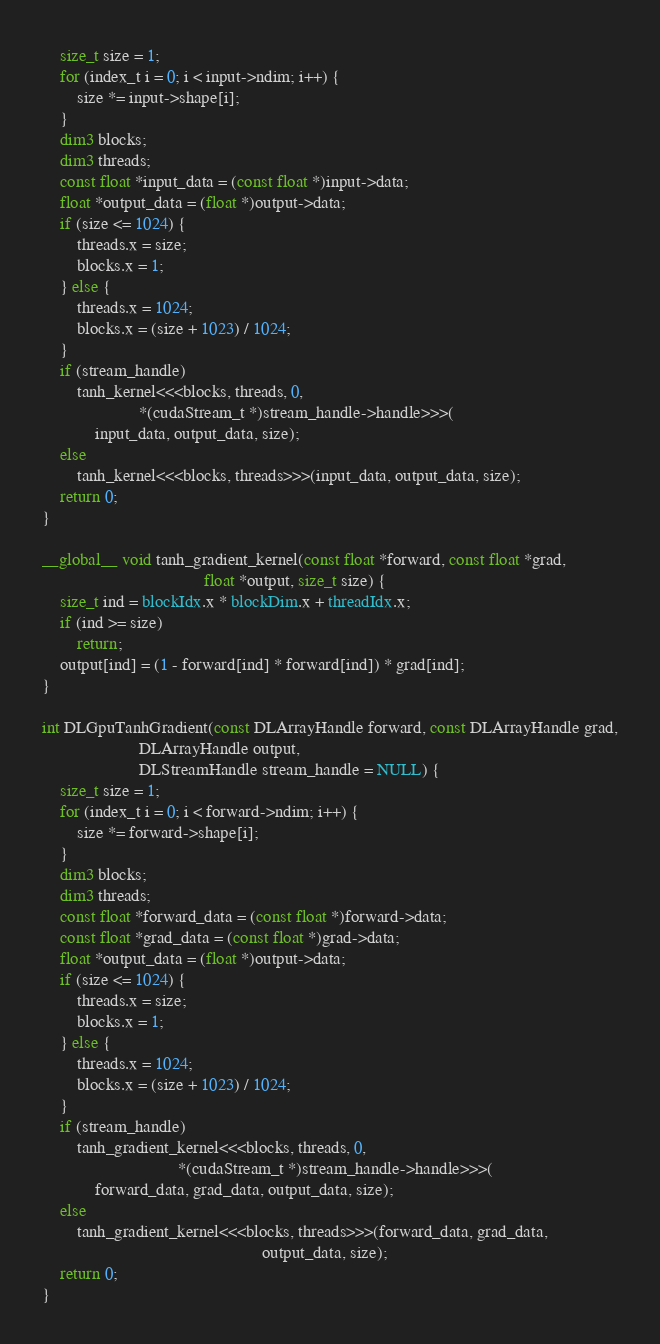<code> <loc_0><loc_0><loc_500><loc_500><_Cuda_>    size_t size = 1;
    for (index_t i = 0; i < input->ndim; i++) {
        size *= input->shape[i];
    }
    dim3 blocks;
    dim3 threads;
    const float *input_data = (const float *)input->data;
    float *output_data = (float *)output->data;
    if (size <= 1024) {
        threads.x = size;
        blocks.x = 1;
    } else {
        threads.x = 1024;
        blocks.x = (size + 1023) / 1024;
    }
    if (stream_handle)
        tanh_kernel<<<blocks, threads, 0,
                      *(cudaStream_t *)stream_handle->handle>>>(
            input_data, output_data, size);
    else
        tanh_kernel<<<blocks, threads>>>(input_data, output_data, size);
    return 0;
}

__global__ void tanh_gradient_kernel(const float *forward, const float *grad,
                                     float *output, size_t size) {
    size_t ind = blockIdx.x * blockDim.x + threadIdx.x;
    if (ind >= size)
        return;
    output[ind] = (1 - forward[ind] * forward[ind]) * grad[ind];
}

int DLGpuTanhGradient(const DLArrayHandle forward, const DLArrayHandle grad,
                      DLArrayHandle output,
                      DLStreamHandle stream_handle = NULL) {
    size_t size = 1;
    for (index_t i = 0; i < forward->ndim; i++) {
        size *= forward->shape[i];
    }
    dim3 blocks;
    dim3 threads;
    const float *forward_data = (const float *)forward->data;
    const float *grad_data = (const float *)grad->data;
    float *output_data = (float *)output->data;
    if (size <= 1024) {
        threads.x = size;
        blocks.x = 1;
    } else {
        threads.x = 1024;
        blocks.x = (size + 1023) / 1024;
    }
    if (stream_handle)
        tanh_gradient_kernel<<<blocks, threads, 0,
                               *(cudaStream_t *)stream_handle->handle>>>(
            forward_data, grad_data, output_data, size);
    else
        tanh_gradient_kernel<<<blocks, threads>>>(forward_data, grad_data,
                                                  output_data, size);
    return 0;
}</code> 